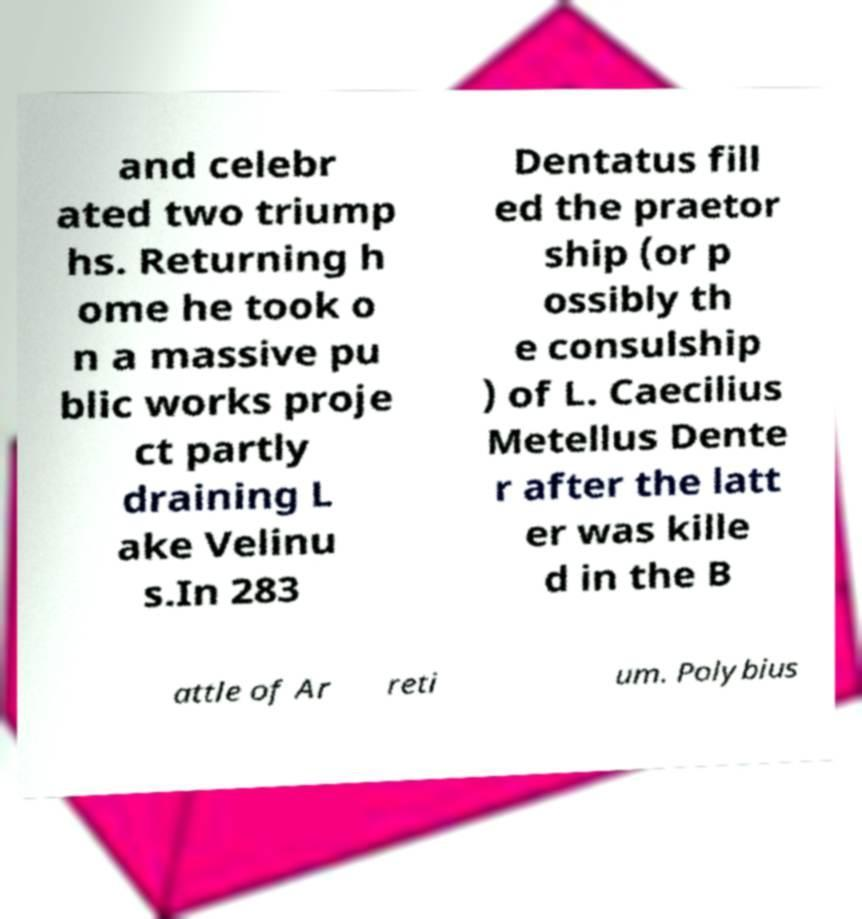Please identify and transcribe the text found in this image. and celebr ated two triump hs. Returning h ome he took o n a massive pu blic works proje ct partly draining L ake Velinu s.In 283 Dentatus fill ed the praetor ship (or p ossibly th e consulship ) of L. Caecilius Metellus Dente r after the latt er was kille d in the B attle of Ar reti um. Polybius 